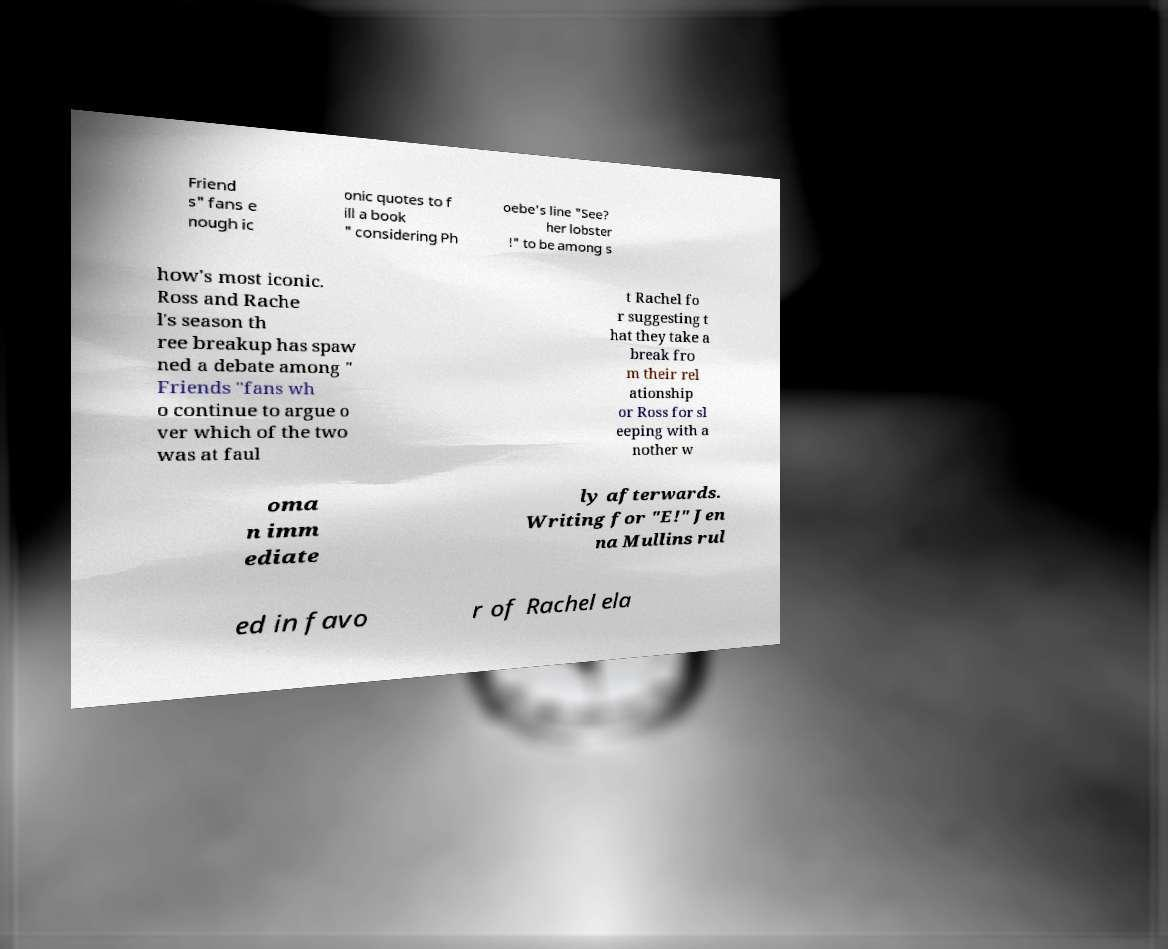I need the written content from this picture converted into text. Can you do that? Friend s" fans e nough ic onic quotes to f ill a book " considering Ph oebe's line "See? her lobster !" to be among s how's most iconic. Ross and Rache l's season th ree breakup has spaw ned a debate among " Friends "fans wh o continue to argue o ver which of the two was at faul t Rachel fo r suggesting t hat they take a break fro m their rel ationship or Ross for sl eeping with a nother w oma n imm ediate ly afterwards. Writing for "E!" Jen na Mullins rul ed in favo r of Rachel ela 